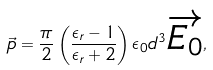Convert formula to latex. <formula><loc_0><loc_0><loc_500><loc_500>\vec { p } = \frac { \pi } { 2 } \left ( \frac { \epsilon _ { r } - 1 } { \epsilon _ { r } + 2 } \right ) \epsilon _ { 0 } d ^ { 3 } \overrightarrow { E _ { 0 } } ,</formula> 